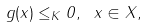Convert formula to latex. <formula><loc_0><loc_0><loc_500><loc_500>g ( x ) \leq _ { K } 0 , \ x \in X ,</formula> 